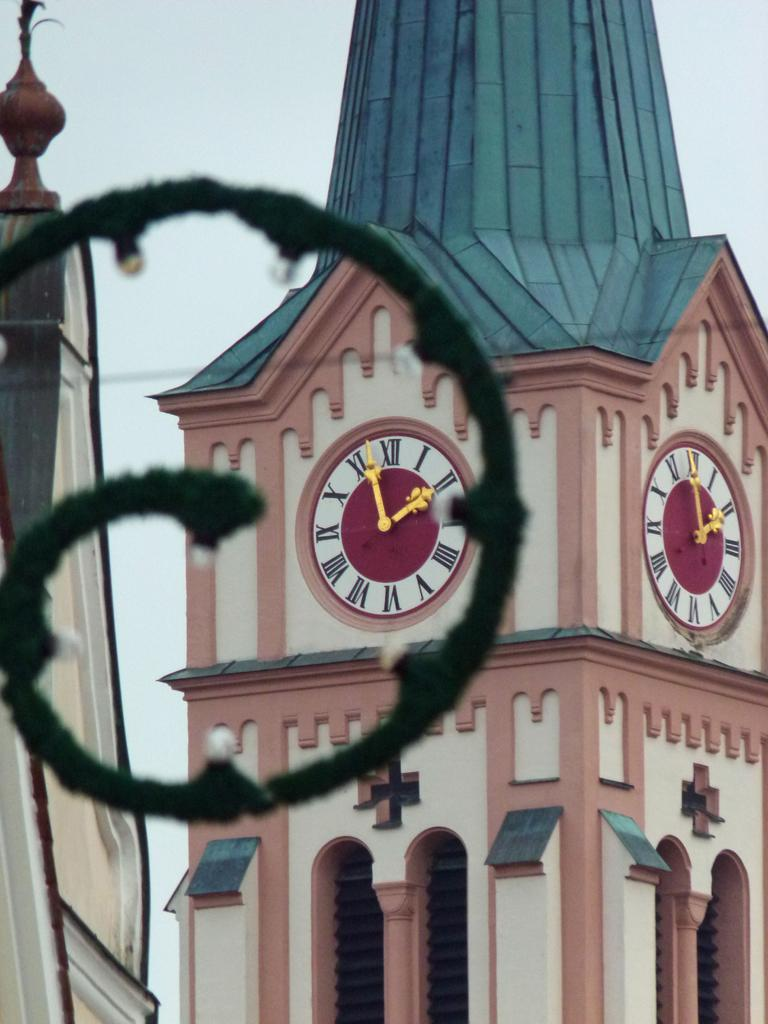What is the main structure in the image? There is a clock tower in the image. What features can be seen on the clock tower? The clock tower has clocks and windows. What can be seen in the background of the image? The sky is visible in the background of the image. What type of object with bulbs is present in the image? There is an object with bulbs in the image, but we cannot determine its specific purpose or function from the given facts. How is the group of insurance agents distributed around the clock tower in the image? There is no mention of a group of insurance agents in the image, so we cannot answer this question. 